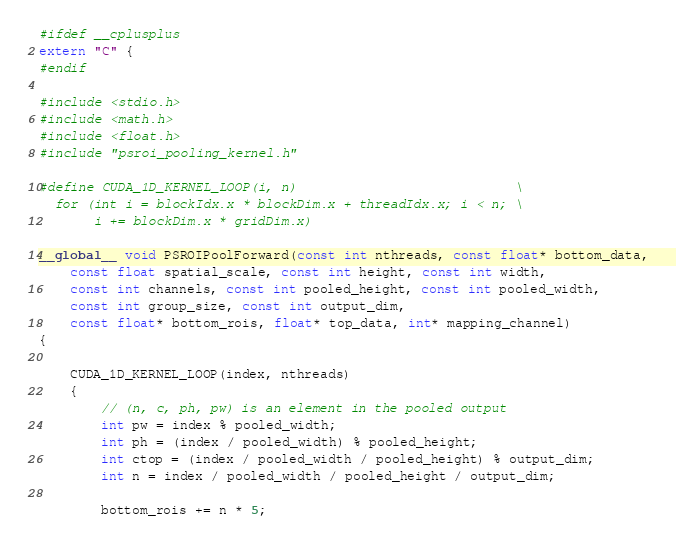<code> <loc_0><loc_0><loc_500><loc_500><_Cuda_>#ifdef __cplusplus
extern "C" {
#endif

#include <stdio.h>
#include <math.h>
#include <float.h>
#include "psroi_pooling_kernel.h"

#define CUDA_1D_KERNEL_LOOP(i, n)                            \
  for (int i = blockIdx.x * blockDim.x + threadIdx.x; i < n; \
       i += blockDim.x * gridDim.x)

__global__ void PSROIPoolForward(const int nthreads, const float* bottom_data,
    const float spatial_scale, const int height, const int width,
    const int channels, const int pooled_height, const int pooled_width,
    const int group_size, const int output_dim,
    const float* bottom_rois, float* top_data, int* mapping_channel)
{

    CUDA_1D_KERNEL_LOOP(index, nthreads)
    {
        // (n, c, ph, pw) is an element in the pooled output
        int pw = index % pooled_width;
      	int ph = (index / pooled_width) % pooled_height;
      	int ctop = (index / pooled_width / pooled_height) % output_dim;
      	int n = index / pooled_width / pooled_height / output_dim;

        bottom_rois += n * 5;</code> 